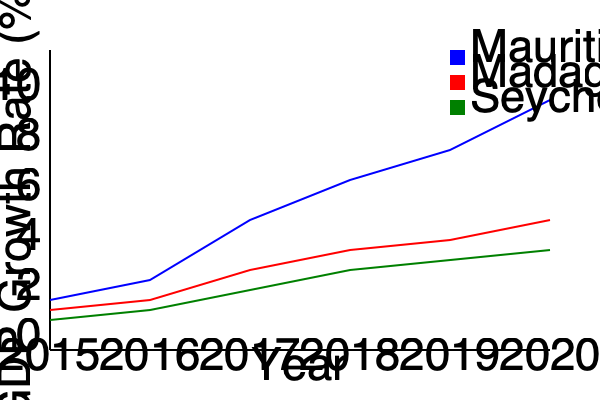Based on the line graph comparing the economic growth rates of Mauritius and its neighboring countries from 2015 to 2020, which country has shown the most consistent upward trend in GDP growth rate, and how might this impact regional economic dynamics? To answer this question, we need to analyze the trends for each country:

1. Mauritius (blue line):
   - Shows a clear upward trend from 2015 to 2020
   - Growth rate increases from about 3% to 8% over the period
   - The line is relatively smooth, indicating consistent growth

2. Madagascar (red line):
   - Shows a slight upward trend, but less pronounced than Mauritius
   - Growth rate increases from about 2% to 5% over the period
   - The line has some fluctuations, indicating less consistent growth

3. Seychelles (green line):
   - Shows the least growth among the three countries
   - Growth rate increases only slightly from about 1.5% to 3.5%
   - The line is relatively flat, indicating slow but steady growth

Mauritius clearly shows the most consistent upward trend in GDP growth rate. This consistent growth can impact regional economic dynamics in several ways:

1. Increased foreign investment: Mauritius may attract more foreign direct investment due to its stable economic growth.
2. Regional economic hub: Mauritius could become a more prominent economic center in the region, potentially leading to increased trade and partnerships with neighboring countries.
3. Economic disparity: The gap between Mauritius and its neighbors may widen, potentially leading to increased migration or economic tensions in the region.
4. Policy influence: Mauritius's economic success might influence neighboring countries to adopt similar economic policies or seek closer cooperation with Mauritius.
5. Competitive advantage: Mauritius may gain a stronger position in regional and global markets, potentially affecting the competitiveness of its neighbors.

These factors could lead to a shift in regional economic power dynamics, with Mauritius potentially emerging as a more influential player in the Indian Ocean region.
Answer: Mauritius shows the most consistent upward trend, potentially leading to increased regional influence and economic disparities. 